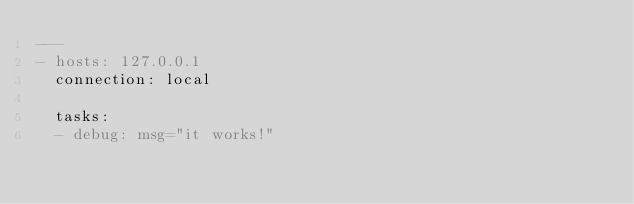Convert code to text. <code><loc_0><loc_0><loc_500><loc_500><_YAML_>---
- hosts: 127.0.0.1
  connection: local
  
  tasks:
  - debug: msg="it works!"</code> 